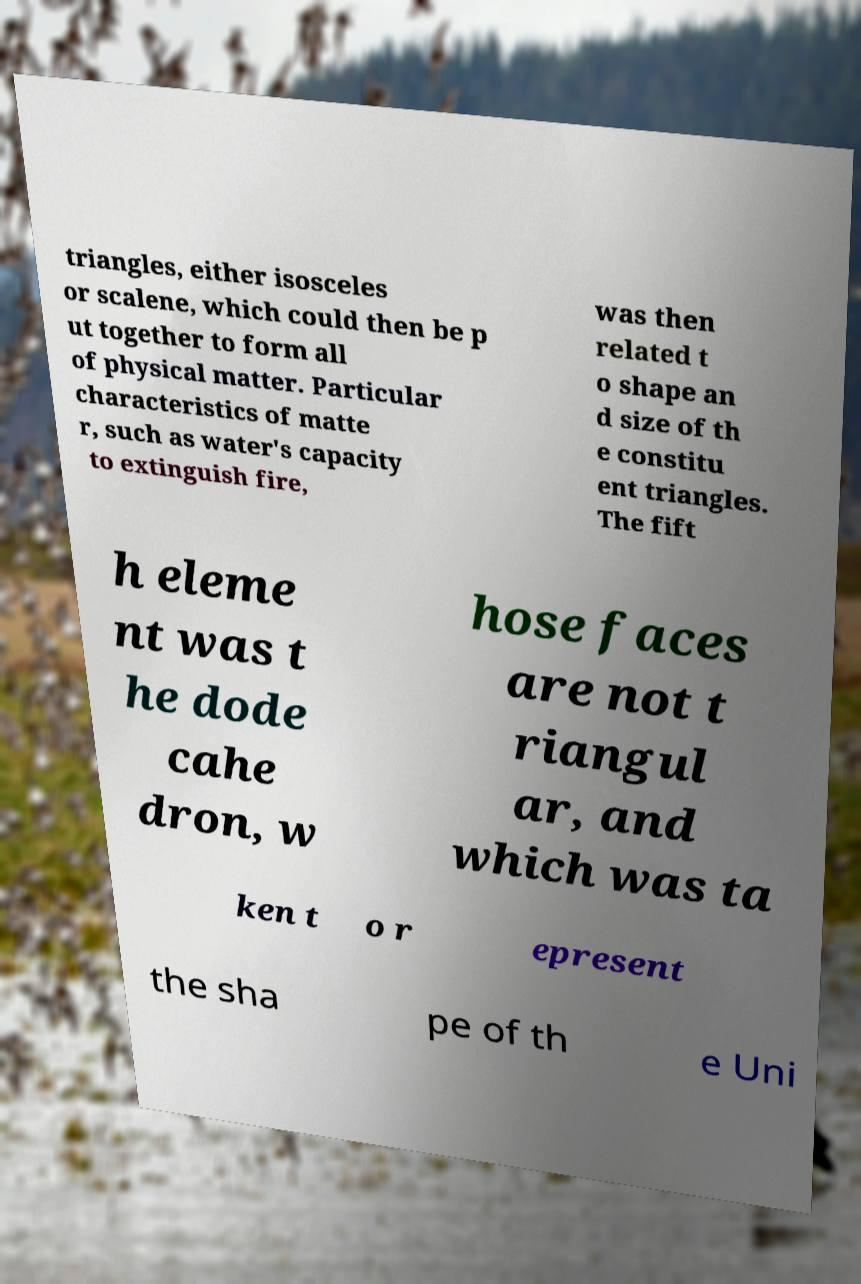Please identify and transcribe the text found in this image. triangles, either isosceles or scalene, which could then be p ut together to form all of physical matter. Particular characteristics of matte r, such as water's capacity to extinguish fire, was then related t o shape an d size of th e constitu ent triangles. The fift h eleme nt was t he dode cahe dron, w hose faces are not t riangul ar, and which was ta ken t o r epresent the sha pe of th e Uni 